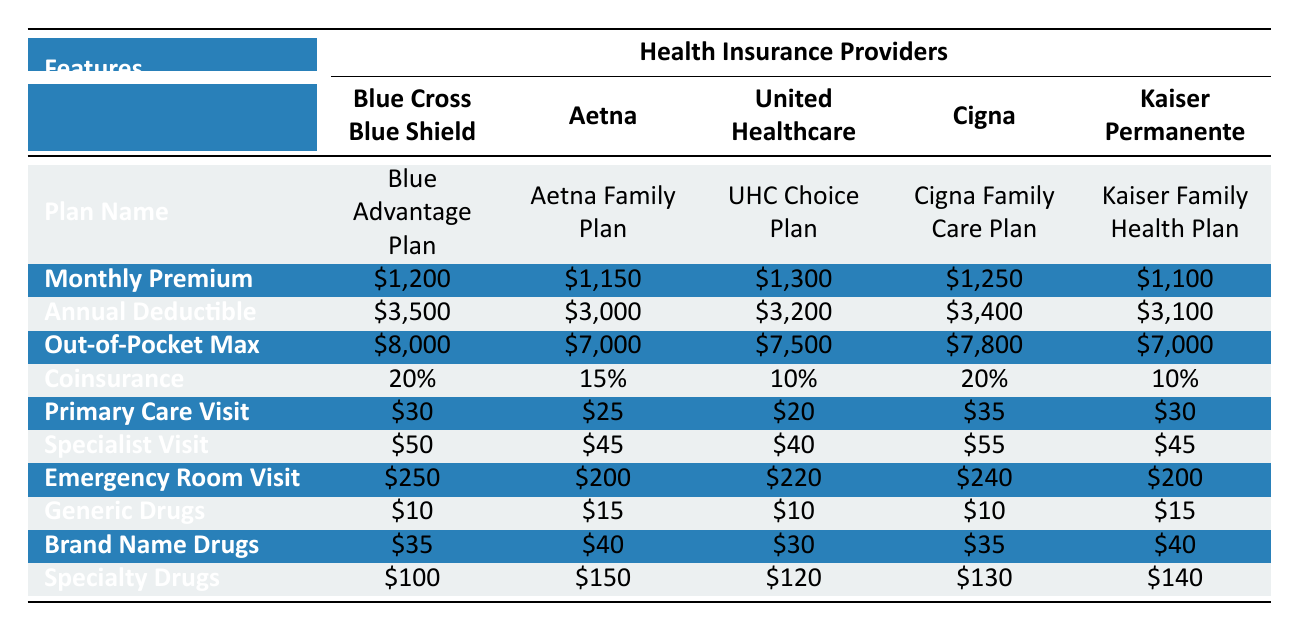What is the monthly premium for the Aetna Family Plan? The table lists the monthly premium for the Aetna Family Plan under the "Monthly Premium" row in the Aetna column. The premium is shown as $1,150.
Answer: $1,150 Which plan has the highest annual deductible? To find the highest annual deductible, look at the "Annual Deductible" row across all providers. The values are $3,500, $3,000, $3,200, $3,400, and $3,100. The maximum among these is $3,500, which belongs to the Blue Cross Blue Shield plan.
Answer: $3,500 Is the specialist visit cost for Kaiser Permanente lower than that for Cigna? The table shows that the specialist visit cost for Kaiser Permanente is $45, and for Cigna, it's $55. Since $45 is less than $55, the statement is true.
Answer: Yes What is the average monthly premium of all the plans? To find the average, sum the monthly premiums: $1,200 + $1,150 + $1,300 + $1,250 + $1,100 = $6,000. There are 5 plans, so the average is $6,000 divided by 5, which equals $1,200.
Answer: $1,200 Which provider offers the lowest out-of-pocket maximum? Analyzing the "Out-of-Pocket Max" row, the values are $8,000, $7,000, $7,500, $7,800, and $7,000. The lowest value, $7,000, is provided by both Aetna and Kaiser Permanente.
Answer: Aetna and Kaiser Permanente What is the difference in cost between the primary care visit of Blue Cross Blue Shield and United Healthcare? The primary care visit cost for Blue Cross Blue Shield is $30, and for United Healthcare, it's $20. The difference is calculated as $30 - $20, which equals $10.
Answer: $10 Is the coinsurance rate the same for Blue Cross Blue Shield and Cigna? The table indicates a coinsurance of 20% for Blue Cross Blue Shield and 20% for Cigna. Since these values are identical, the answer is true.
Answer: Yes Which plan has the highest cost for specialty drugs, and what is the price? Reviewing the "Specialty Drugs" row, the costs are $100 for Blue Cross Blue Shield, $150 for Aetna, $120 for United Healthcare, $130 for Cigna, and $140 for Kaiser Permanente. The highest is $150, associated with Aetna.
Answer: Aetna, $150 